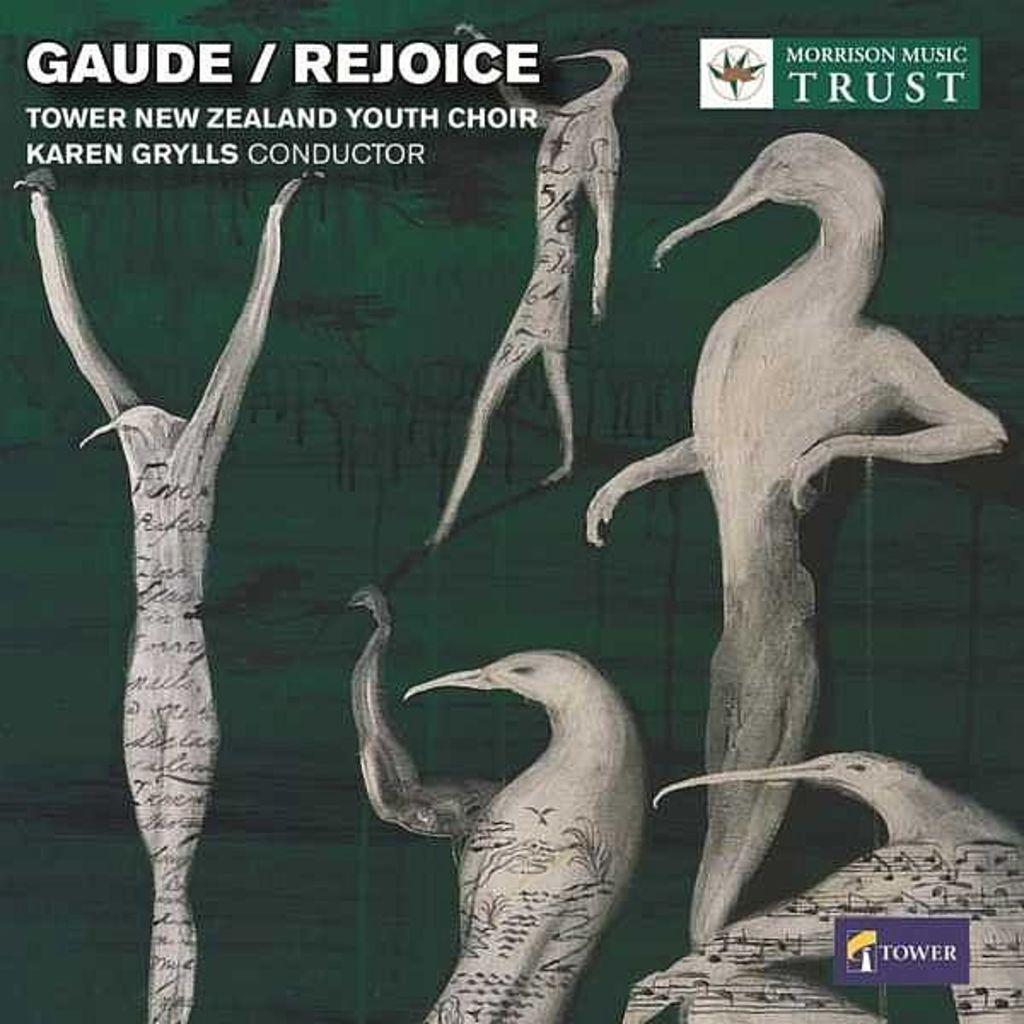What type of sculpture is present in the image? There are five birds in the form of a sculpture in the image. Where can watermarks be found in the image? Watermarks can be found on the left side, right side, and at the bottom of the image. How does the sculpture connect with the middle of the image? The sculpture does not connect with the middle of the image; it is a separate object and not physically attached to the image itself. 